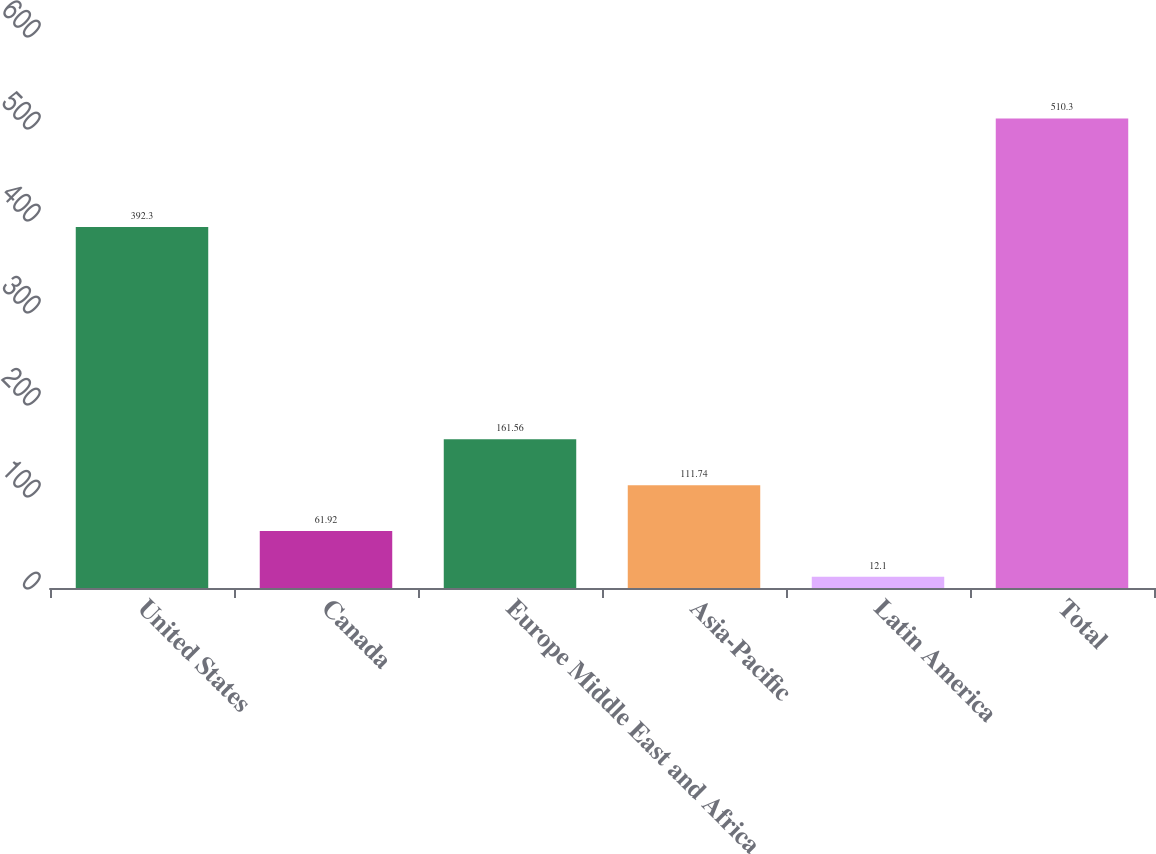Convert chart to OTSL. <chart><loc_0><loc_0><loc_500><loc_500><bar_chart><fcel>United States<fcel>Canada<fcel>Europe Middle East and Africa<fcel>Asia-Pacific<fcel>Latin America<fcel>Total<nl><fcel>392.3<fcel>61.92<fcel>161.56<fcel>111.74<fcel>12.1<fcel>510.3<nl></chart> 